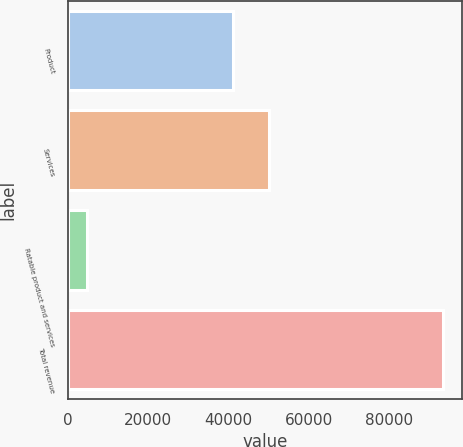<chart> <loc_0><loc_0><loc_500><loc_500><bar_chart><fcel>Product<fcel>Services<fcel>Ratable product and services<fcel>Total revenue<nl><fcel>41080<fcel>49981<fcel>4589<fcel>93599<nl></chart> 